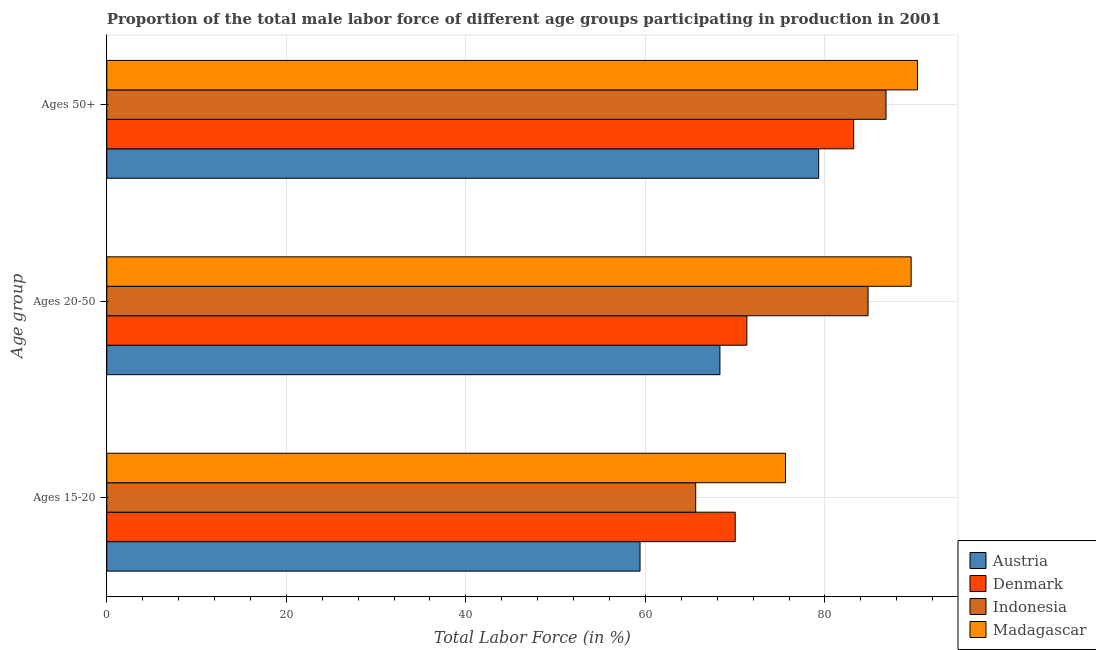How many different coloured bars are there?
Provide a succinct answer. 4. How many groups of bars are there?
Offer a terse response. 3. How many bars are there on the 3rd tick from the top?
Your answer should be compact. 4. What is the label of the 1st group of bars from the top?
Offer a terse response. Ages 50+. What is the percentage of male labor force within the age group 15-20 in Indonesia?
Offer a terse response. 65.6. Across all countries, what is the maximum percentage of male labor force within the age group 20-50?
Offer a very short reply. 89.6. Across all countries, what is the minimum percentage of male labor force above age 50?
Make the answer very short. 79.3. In which country was the percentage of male labor force within the age group 20-50 maximum?
Give a very brief answer. Madagascar. In which country was the percentage of male labor force within the age group 20-50 minimum?
Ensure brevity in your answer.  Austria. What is the total percentage of male labor force within the age group 15-20 in the graph?
Offer a terse response. 270.6. What is the difference between the percentage of male labor force within the age group 20-50 in Denmark and that in Austria?
Ensure brevity in your answer.  3. What is the difference between the percentage of male labor force within the age group 15-20 in Denmark and the percentage of male labor force above age 50 in Austria?
Give a very brief answer. -9.3. What is the average percentage of male labor force above age 50 per country?
Give a very brief answer. 84.9. What is the ratio of the percentage of male labor force above age 50 in Madagascar to that in Indonesia?
Give a very brief answer. 1.04. Is the percentage of male labor force within the age group 20-50 in Madagascar less than that in Austria?
Provide a short and direct response. No. What is the difference between the highest and the second highest percentage of male labor force above age 50?
Provide a short and direct response. 3.5. What is the difference between the highest and the lowest percentage of male labor force above age 50?
Provide a succinct answer. 11. Are the values on the major ticks of X-axis written in scientific E-notation?
Your response must be concise. No. Does the graph contain grids?
Offer a terse response. Yes. Where does the legend appear in the graph?
Your response must be concise. Bottom right. What is the title of the graph?
Provide a short and direct response. Proportion of the total male labor force of different age groups participating in production in 2001. What is the label or title of the X-axis?
Your answer should be compact. Total Labor Force (in %). What is the label or title of the Y-axis?
Provide a short and direct response. Age group. What is the Total Labor Force (in %) in Austria in Ages 15-20?
Offer a very short reply. 59.4. What is the Total Labor Force (in %) in Denmark in Ages 15-20?
Offer a terse response. 70. What is the Total Labor Force (in %) of Indonesia in Ages 15-20?
Your answer should be compact. 65.6. What is the Total Labor Force (in %) in Madagascar in Ages 15-20?
Offer a terse response. 75.6. What is the Total Labor Force (in %) in Austria in Ages 20-50?
Offer a very short reply. 68.3. What is the Total Labor Force (in %) of Denmark in Ages 20-50?
Provide a succinct answer. 71.3. What is the Total Labor Force (in %) in Indonesia in Ages 20-50?
Provide a short and direct response. 84.8. What is the Total Labor Force (in %) of Madagascar in Ages 20-50?
Keep it short and to the point. 89.6. What is the Total Labor Force (in %) of Austria in Ages 50+?
Provide a short and direct response. 79.3. What is the Total Labor Force (in %) in Denmark in Ages 50+?
Offer a very short reply. 83.2. What is the Total Labor Force (in %) of Indonesia in Ages 50+?
Give a very brief answer. 86.8. What is the Total Labor Force (in %) in Madagascar in Ages 50+?
Provide a short and direct response. 90.3. Across all Age group, what is the maximum Total Labor Force (in %) of Austria?
Your answer should be compact. 79.3. Across all Age group, what is the maximum Total Labor Force (in %) in Denmark?
Provide a succinct answer. 83.2. Across all Age group, what is the maximum Total Labor Force (in %) in Indonesia?
Provide a succinct answer. 86.8. Across all Age group, what is the maximum Total Labor Force (in %) in Madagascar?
Your answer should be compact. 90.3. Across all Age group, what is the minimum Total Labor Force (in %) in Austria?
Make the answer very short. 59.4. Across all Age group, what is the minimum Total Labor Force (in %) of Indonesia?
Give a very brief answer. 65.6. Across all Age group, what is the minimum Total Labor Force (in %) of Madagascar?
Provide a succinct answer. 75.6. What is the total Total Labor Force (in %) in Austria in the graph?
Offer a very short reply. 207. What is the total Total Labor Force (in %) in Denmark in the graph?
Ensure brevity in your answer.  224.5. What is the total Total Labor Force (in %) in Indonesia in the graph?
Your answer should be very brief. 237.2. What is the total Total Labor Force (in %) in Madagascar in the graph?
Offer a terse response. 255.5. What is the difference between the Total Labor Force (in %) of Austria in Ages 15-20 and that in Ages 20-50?
Make the answer very short. -8.9. What is the difference between the Total Labor Force (in %) in Denmark in Ages 15-20 and that in Ages 20-50?
Make the answer very short. -1.3. What is the difference between the Total Labor Force (in %) of Indonesia in Ages 15-20 and that in Ages 20-50?
Ensure brevity in your answer.  -19.2. What is the difference between the Total Labor Force (in %) of Madagascar in Ages 15-20 and that in Ages 20-50?
Offer a terse response. -14. What is the difference between the Total Labor Force (in %) of Austria in Ages 15-20 and that in Ages 50+?
Make the answer very short. -19.9. What is the difference between the Total Labor Force (in %) in Denmark in Ages 15-20 and that in Ages 50+?
Your answer should be compact. -13.2. What is the difference between the Total Labor Force (in %) of Indonesia in Ages 15-20 and that in Ages 50+?
Offer a very short reply. -21.2. What is the difference between the Total Labor Force (in %) of Madagascar in Ages 15-20 and that in Ages 50+?
Ensure brevity in your answer.  -14.7. What is the difference between the Total Labor Force (in %) in Austria in Ages 20-50 and that in Ages 50+?
Your answer should be very brief. -11. What is the difference between the Total Labor Force (in %) in Indonesia in Ages 20-50 and that in Ages 50+?
Provide a succinct answer. -2. What is the difference between the Total Labor Force (in %) of Austria in Ages 15-20 and the Total Labor Force (in %) of Denmark in Ages 20-50?
Ensure brevity in your answer.  -11.9. What is the difference between the Total Labor Force (in %) of Austria in Ages 15-20 and the Total Labor Force (in %) of Indonesia in Ages 20-50?
Keep it short and to the point. -25.4. What is the difference between the Total Labor Force (in %) of Austria in Ages 15-20 and the Total Labor Force (in %) of Madagascar in Ages 20-50?
Give a very brief answer. -30.2. What is the difference between the Total Labor Force (in %) in Denmark in Ages 15-20 and the Total Labor Force (in %) in Indonesia in Ages 20-50?
Your response must be concise. -14.8. What is the difference between the Total Labor Force (in %) of Denmark in Ages 15-20 and the Total Labor Force (in %) of Madagascar in Ages 20-50?
Provide a short and direct response. -19.6. What is the difference between the Total Labor Force (in %) of Indonesia in Ages 15-20 and the Total Labor Force (in %) of Madagascar in Ages 20-50?
Keep it short and to the point. -24. What is the difference between the Total Labor Force (in %) in Austria in Ages 15-20 and the Total Labor Force (in %) in Denmark in Ages 50+?
Make the answer very short. -23.8. What is the difference between the Total Labor Force (in %) in Austria in Ages 15-20 and the Total Labor Force (in %) in Indonesia in Ages 50+?
Provide a short and direct response. -27.4. What is the difference between the Total Labor Force (in %) of Austria in Ages 15-20 and the Total Labor Force (in %) of Madagascar in Ages 50+?
Make the answer very short. -30.9. What is the difference between the Total Labor Force (in %) of Denmark in Ages 15-20 and the Total Labor Force (in %) of Indonesia in Ages 50+?
Offer a terse response. -16.8. What is the difference between the Total Labor Force (in %) of Denmark in Ages 15-20 and the Total Labor Force (in %) of Madagascar in Ages 50+?
Make the answer very short. -20.3. What is the difference between the Total Labor Force (in %) of Indonesia in Ages 15-20 and the Total Labor Force (in %) of Madagascar in Ages 50+?
Provide a succinct answer. -24.7. What is the difference between the Total Labor Force (in %) of Austria in Ages 20-50 and the Total Labor Force (in %) of Denmark in Ages 50+?
Your response must be concise. -14.9. What is the difference between the Total Labor Force (in %) in Austria in Ages 20-50 and the Total Labor Force (in %) in Indonesia in Ages 50+?
Keep it short and to the point. -18.5. What is the difference between the Total Labor Force (in %) of Austria in Ages 20-50 and the Total Labor Force (in %) of Madagascar in Ages 50+?
Offer a very short reply. -22. What is the difference between the Total Labor Force (in %) in Denmark in Ages 20-50 and the Total Labor Force (in %) in Indonesia in Ages 50+?
Ensure brevity in your answer.  -15.5. What is the average Total Labor Force (in %) in Denmark per Age group?
Your response must be concise. 74.83. What is the average Total Labor Force (in %) of Indonesia per Age group?
Keep it short and to the point. 79.07. What is the average Total Labor Force (in %) of Madagascar per Age group?
Give a very brief answer. 85.17. What is the difference between the Total Labor Force (in %) of Austria and Total Labor Force (in %) of Indonesia in Ages 15-20?
Offer a terse response. -6.2. What is the difference between the Total Labor Force (in %) of Austria and Total Labor Force (in %) of Madagascar in Ages 15-20?
Provide a succinct answer. -16.2. What is the difference between the Total Labor Force (in %) of Denmark and Total Labor Force (in %) of Indonesia in Ages 15-20?
Make the answer very short. 4.4. What is the difference between the Total Labor Force (in %) of Indonesia and Total Labor Force (in %) of Madagascar in Ages 15-20?
Keep it short and to the point. -10. What is the difference between the Total Labor Force (in %) of Austria and Total Labor Force (in %) of Denmark in Ages 20-50?
Your answer should be compact. -3. What is the difference between the Total Labor Force (in %) in Austria and Total Labor Force (in %) in Indonesia in Ages 20-50?
Give a very brief answer. -16.5. What is the difference between the Total Labor Force (in %) of Austria and Total Labor Force (in %) of Madagascar in Ages 20-50?
Provide a succinct answer. -21.3. What is the difference between the Total Labor Force (in %) of Denmark and Total Labor Force (in %) of Indonesia in Ages 20-50?
Ensure brevity in your answer.  -13.5. What is the difference between the Total Labor Force (in %) in Denmark and Total Labor Force (in %) in Madagascar in Ages 20-50?
Your answer should be compact. -18.3. What is the difference between the Total Labor Force (in %) of Indonesia and Total Labor Force (in %) of Madagascar in Ages 20-50?
Give a very brief answer. -4.8. What is the difference between the Total Labor Force (in %) of Austria and Total Labor Force (in %) of Denmark in Ages 50+?
Keep it short and to the point. -3.9. What is the difference between the Total Labor Force (in %) in Austria and Total Labor Force (in %) in Indonesia in Ages 50+?
Offer a very short reply. -7.5. What is the difference between the Total Labor Force (in %) of Denmark and Total Labor Force (in %) of Madagascar in Ages 50+?
Provide a succinct answer. -7.1. What is the difference between the Total Labor Force (in %) in Indonesia and Total Labor Force (in %) in Madagascar in Ages 50+?
Your answer should be very brief. -3.5. What is the ratio of the Total Labor Force (in %) in Austria in Ages 15-20 to that in Ages 20-50?
Your answer should be very brief. 0.87. What is the ratio of the Total Labor Force (in %) in Denmark in Ages 15-20 to that in Ages 20-50?
Offer a very short reply. 0.98. What is the ratio of the Total Labor Force (in %) of Indonesia in Ages 15-20 to that in Ages 20-50?
Give a very brief answer. 0.77. What is the ratio of the Total Labor Force (in %) in Madagascar in Ages 15-20 to that in Ages 20-50?
Provide a succinct answer. 0.84. What is the ratio of the Total Labor Force (in %) of Austria in Ages 15-20 to that in Ages 50+?
Provide a succinct answer. 0.75. What is the ratio of the Total Labor Force (in %) of Denmark in Ages 15-20 to that in Ages 50+?
Your response must be concise. 0.84. What is the ratio of the Total Labor Force (in %) of Indonesia in Ages 15-20 to that in Ages 50+?
Keep it short and to the point. 0.76. What is the ratio of the Total Labor Force (in %) in Madagascar in Ages 15-20 to that in Ages 50+?
Offer a very short reply. 0.84. What is the ratio of the Total Labor Force (in %) of Austria in Ages 20-50 to that in Ages 50+?
Keep it short and to the point. 0.86. What is the ratio of the Total Labor Force (in %) in Denmark in Ages 20-50 to that in Ages 50+?
Your answer should be compact. 0.86. What is the ratio of the Total Labor Force (in %) in Indonesia in Ages 20-50 to that in Ages 50+?
Provide a succinct answer. 0.98. What is the difference between the highest and the second highest Total Labor Force (in %) of Madagascar?
Ensure brevity in your answer.  0.7. What is the difference between the highest and the lowest Total Labor Force (in %) of Denmark?
Ensure brevity in your answer.  13.2. What is the difference between the highest and the lowest Total Labor Force (in %) in Indonesia?
Provide a short and direct response. 21.2. 